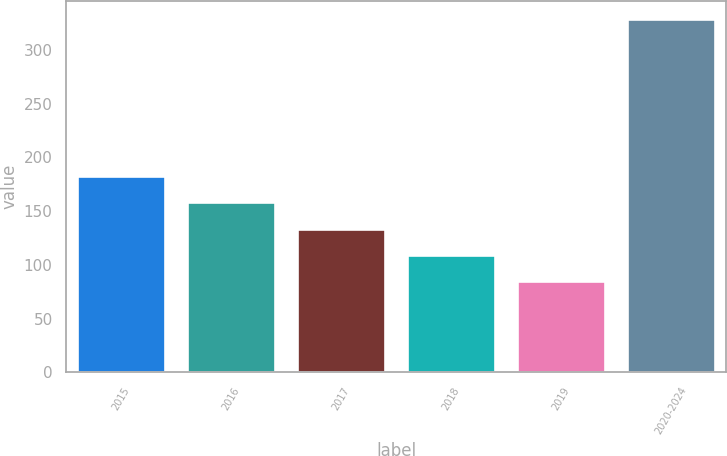Convert chart. <chart><loc_0><loc_0><loc_500><loc_500><bar_chart><fcel>2015<fcel>2016<fcel>2017<fcel>2018<fcel>2019<fcel>2020-2024<nl><fcel>182.6<fcel>158.2<fcel>133.8<fcel>109.4<fcel>85<fcel>329<nl></chart> 